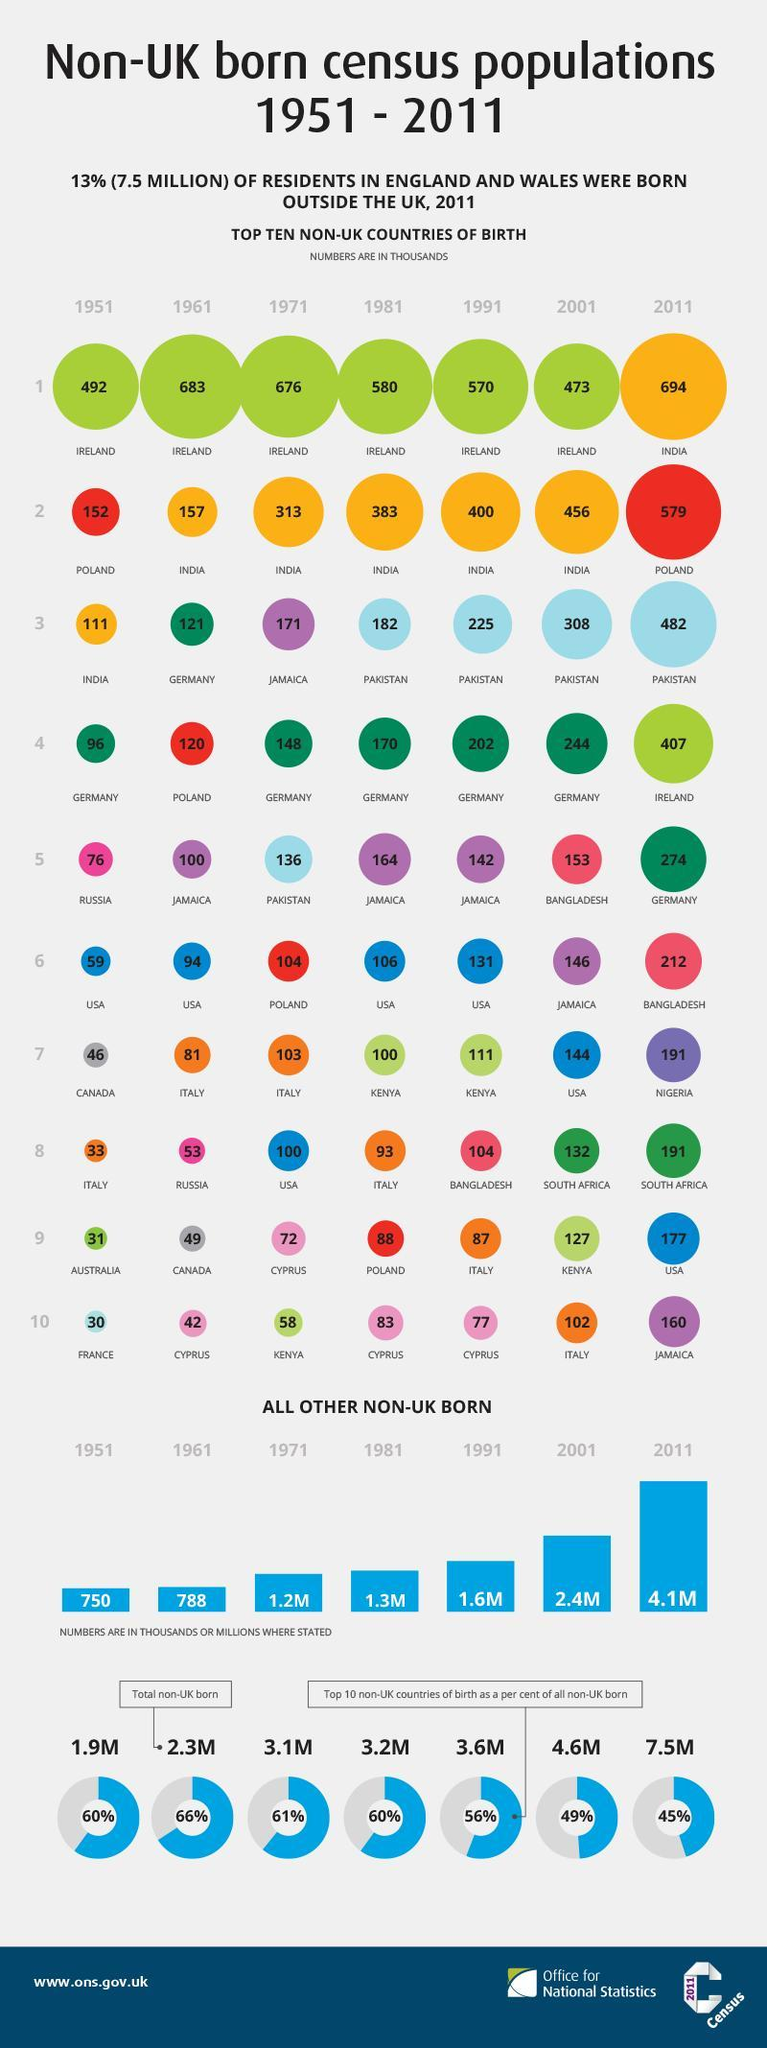What is the total population of non-UK born residents in 2001?
Answer the question with a short phrase. 4.6M What is the total population of non-UK born residents in 2011? 7.5M How many non-UK born residents (in thousands) are from Germany in 1961? 121 How many non-UK born residents (in thousands) are from India in 2001 ? 456 What is the total population of non-UK born residents in 1981? 3.2M What is the total population of non-UK born residents in 1951? 1.9M How many non-UK born residents (in thousands) are from Pakistan in 2011? 482 How many non-UK born residents (in thousands) are from Ireland in 2011? 407 